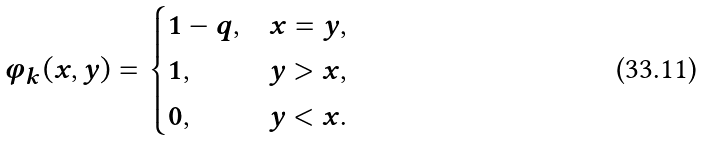Convert formula to latex. <formula><loc_0><loc_0><loc_500><loc_500>\varphi _ { k } ( x , y ) = \begin{cases} 1 - q , & x = y , \\ 1 , & y > x , \\ 0 , & y < x . \end{cases}</formula> 